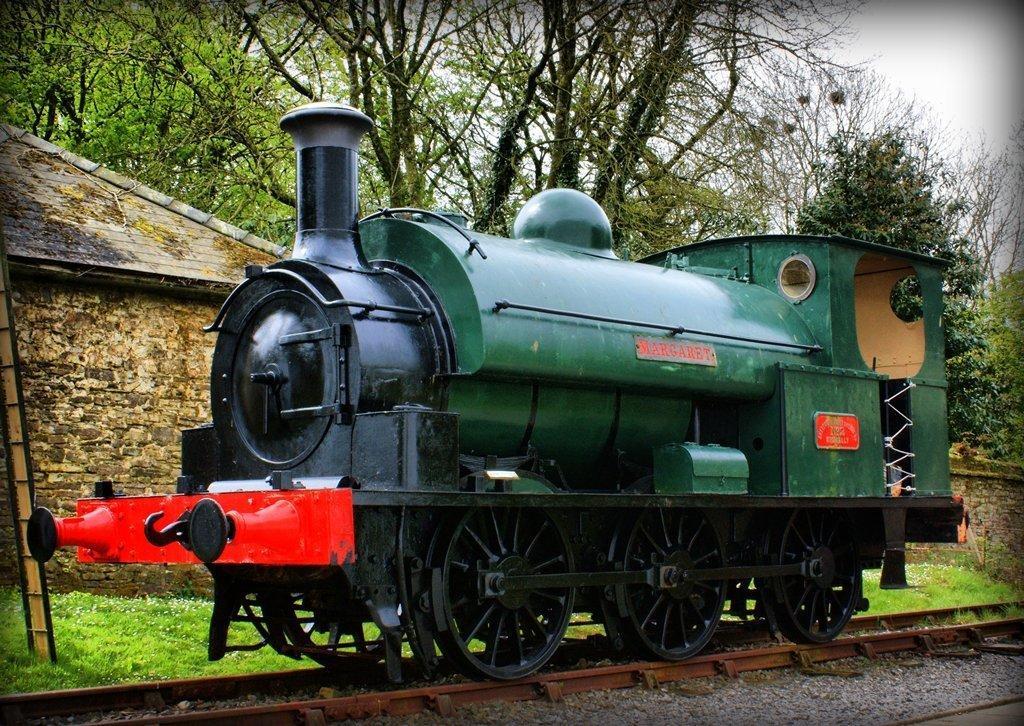In one or two sentences, can you explain what this image depicts? In the background we can see the sky, trees, rooftop, grass and the wall. On the left side of the picture we can see a ladder. In this picture we can see an engine on the track. 